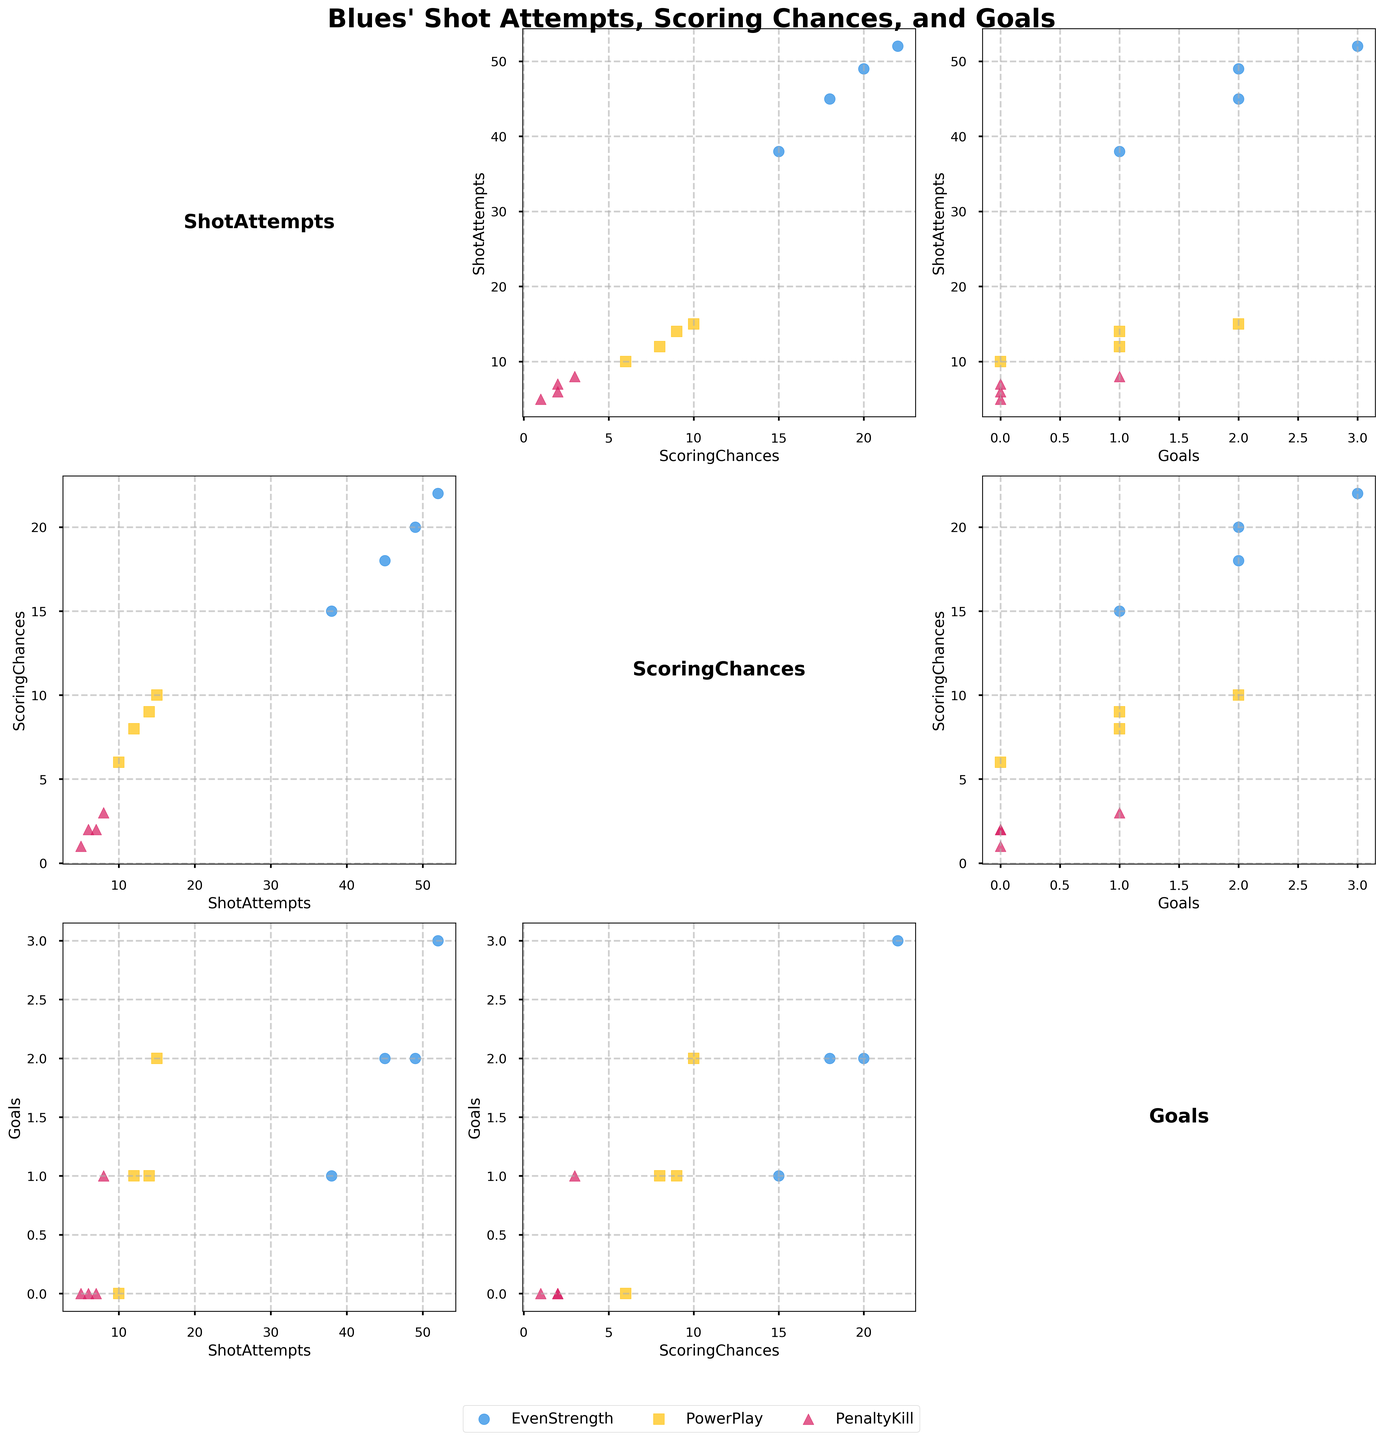What is the title of the plot? The plot title is written at the top center of the figure in a prominent font. It provides an overview of the subject being analyzed in the plot.
Answer: Blues' Shot Attempts, Scoring Chances, and Goals How many variables are displayed in the scatterplot matrix? Each unique plot in the matrix represents a relationship between pairs of these variables. By counting the rows/columns labeled with variable names, we can determine the number of variables.
Answer: 3 Which game situations are distinguished in the scatterplot, and how are they represented? The figure uses different colors and markers to represent distinct game situations. These visual cues should be identified from the legend, illustrating Even Strength, Power Play, and Penalty Kill.
Answer: Even Strength (blue circles), Power Play (yellow squares), Penalty Kill (pink triangles) Which variable has the highest range of values in the scatterplot matrix? By observing the axis scales for each variable, determine which variable spans the largest numerical range across all subplots.
Answer: ShotAttempts Is there an evident clustering of data points for any specific game situation in any pairwise comparison? Look for concentrated groups of data points within a subplot, marked by distinct shapes/colors denoting game situations. Identify any visible clustering.
Answer: Yes, PowerPlay data points tend to cluster at higher Scoring Chances and Goals How many data points reflect Blues achieving at least two goals in any situation? Focus on subplots with 'Goals' on one axis and count data points where 'Goals' value is 2 or more, across all game situations.
Answer: 5 Compare the relationship between Shot Attempts and Goals for Power Play and Penalty Kill situations. Which situation shows a stronger relationship? Analyze subplots displaying Shot Attempts vs. Goals, noting trends in each game situation. A stronger relationship indicates a clearer pattern or trend.
Answer: Power Play Which game situation shows the least number of Shot Attempts? Examine the subplots with 'ShotAttempts' axis, focusing on data points marked for each situation. Identify the game situation with the smallest count.
Answer: Penalty Kill Are there any instances where the Blues have high Scoring Chances but low Goals? Specify the game situations. In subplots comparing Scoring Chances vs. Goals, identify points with high values of Scoring Chances but low Goals. Note their game situations based on markers.
Answer: Yes, Even Strength and Power Play How does the distribution of Scoring Chances compare between Even Strength and Power Play? Check subplots involving Scoring Chances, comparing the spread and concentration of values between these two situations.
Answer: Power Play situations generally have higher Scoring Chances 